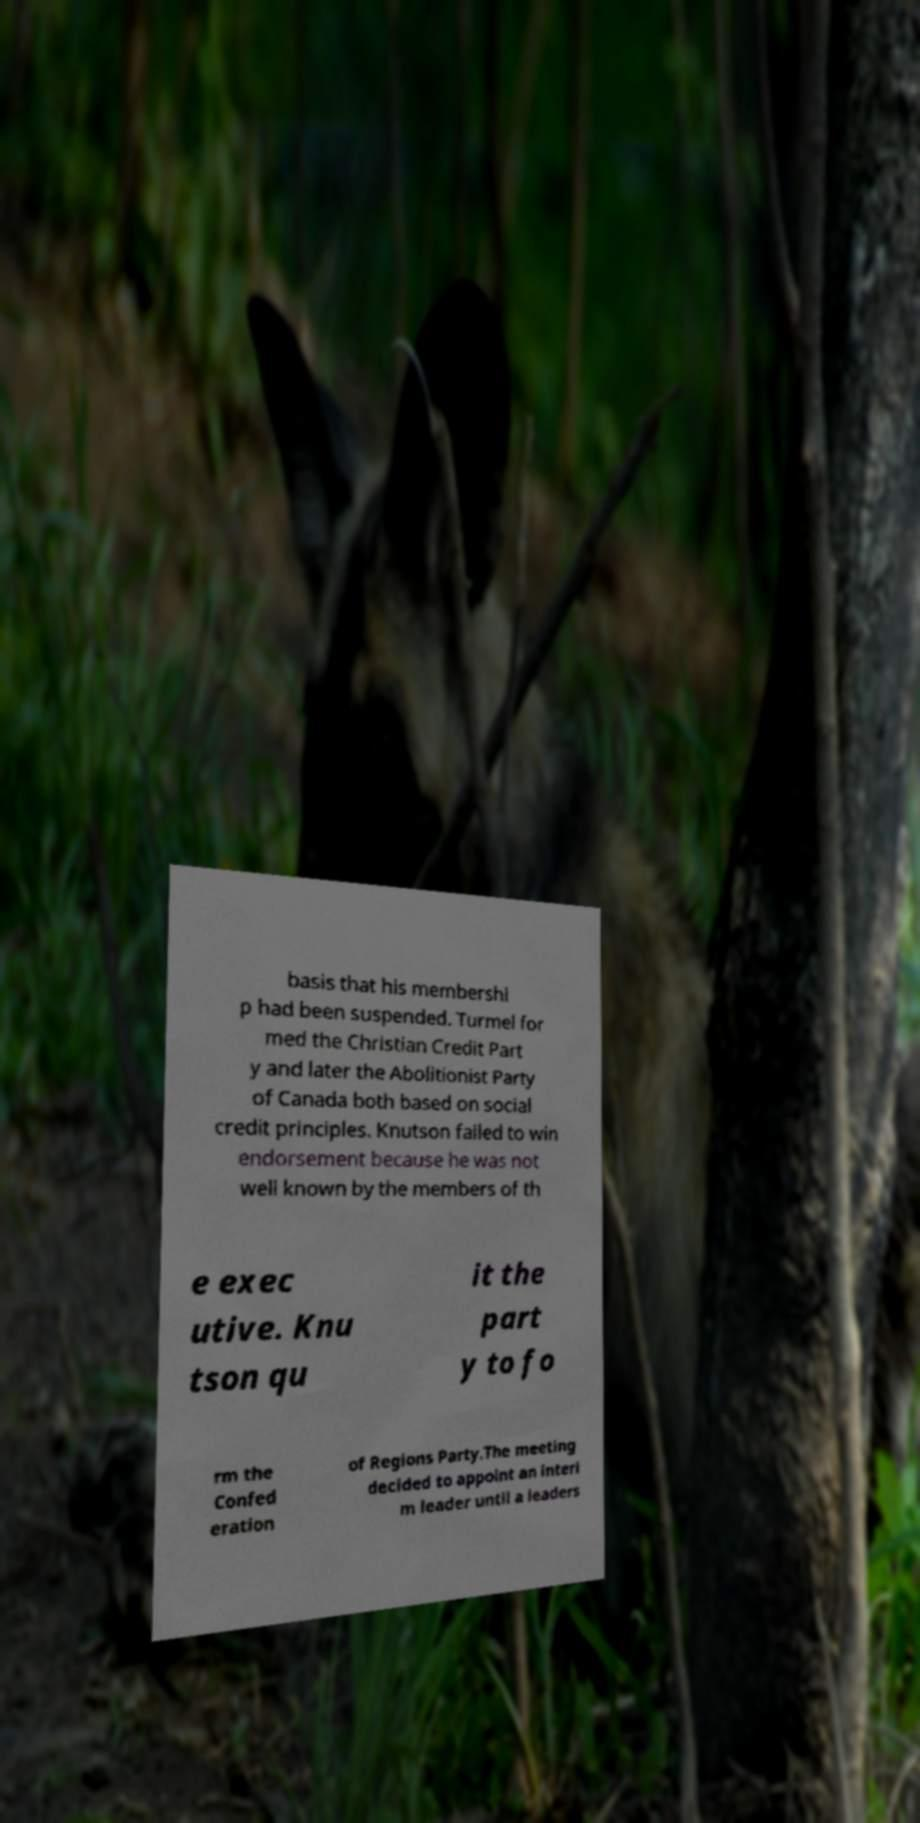Can you read and provide the text displayed in the image?This photo seems to have some interesting text. Can you extract and type it out for me? basis that his membershi p had been suspended. Turmel for med the Christian Credit Part y and later the Abolitionist Party of Canada both based on social credit principles. Knutson failed to win endorsement because he was not well known by the members of th e exec utive. Knu tson qu it the part y to fo rm the Confed eration of Regions Party.The meeting decided to appoint an interi m leader until a leaders 